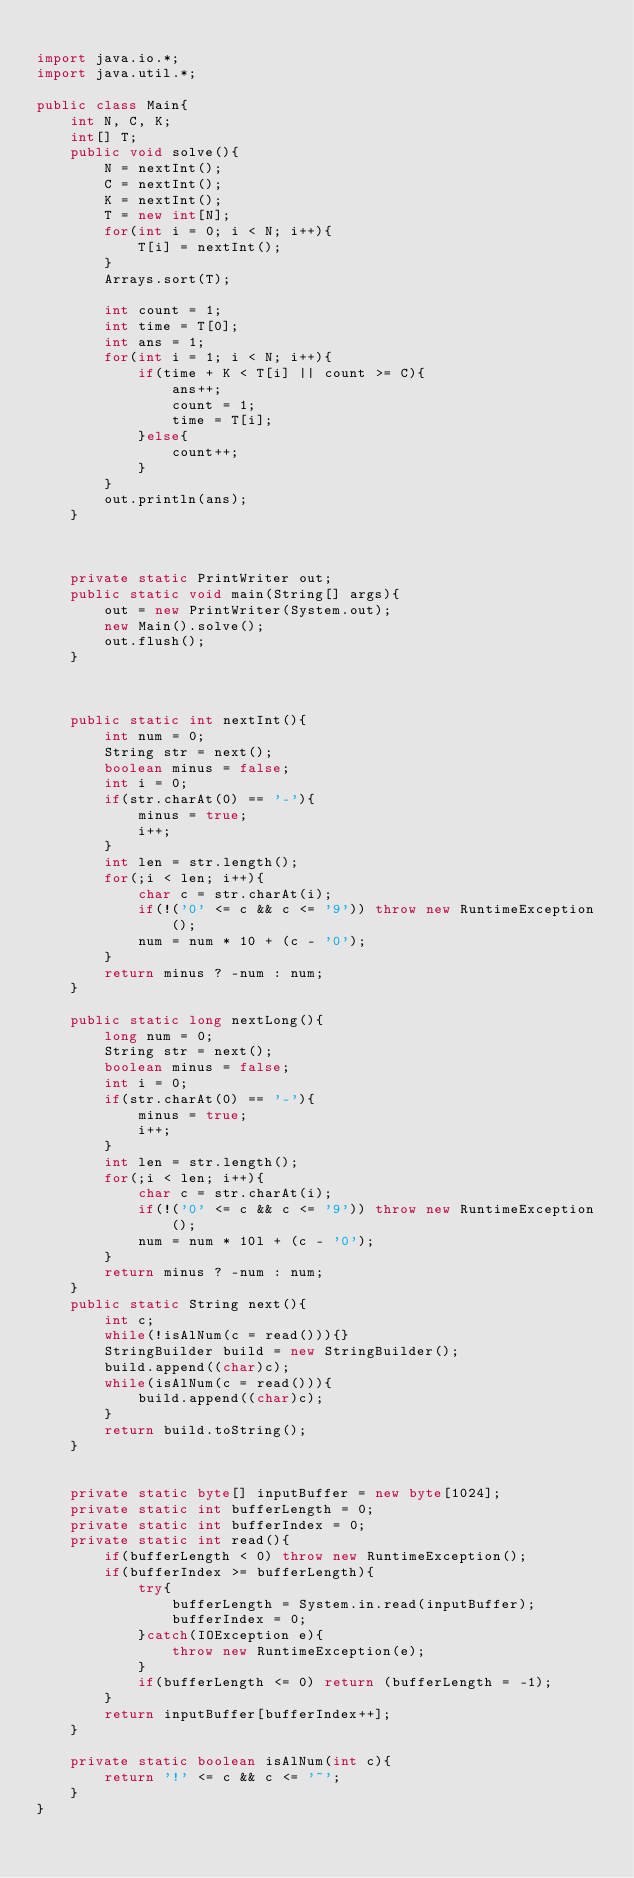Convert code to text. <code><loc_0><loc_0><loc_500><loc_500><_Java_>
import java.io.*;
import java.util.*;
 
public class Main{
	int N, C, K;
	int[] T;
	public void solve(){
		N = nextInt();
		C = nextInt();
		K = nextInt();
		T = new int[N];
		for(int i = 0; i < N; i++){
			T[i] = nextInt();
		}
		Arrays.sort(T);
		
		int count = 1;
		int time = T[0];
		int ans = 1;
		for(int i = 1; i < N; i++){
			if(time + K < T[i] || count >= C){
				ans++;
				count = 1;
				time = T[i];
			}else{
				count++;
			}
		}
		out.println(ans);
	}
	

	
	private static PrintWriter out;
	public static void main(String[] args){
		out = new PrintWriter(System.out);
		new Main().solve();
		out.flush();
	}
	
	
	
	public static int nextInt(){
		int num = 0;
		String str = next();
		boolean minus = false;
		int i = 0;
		if(str.charAt(0) == '-'){
			minus = true;
			i++;
		}
		int len = str.length();
		for(;i < len; i++){
			char c = str.charAt(i);
			if(!('0' <= c && c <= '9')) throw new RuntimeException();
			num = num * 10 + (c - '0');
		}
		return minus ? -num : num;
	}
	
	public static long nextLong(){
		long num = 0;
		String str = next();
		boolean minus = false;
		int i = 0;
		if(str.charAt(0) == '-'){
			minus = true;
			i++;
		}
		int len = str.length();
		for(;i < len; i++){
			char c = str.charAt(i);
			if(!('0' <= c && c <= '9')) throw new RuntimeException();
			num = num * 10l + (c - '0');
		}
		return minus ? -num : num;
	}
	public static String next(){
		int c;
		while(!isAlNum(c = read())){}
		StringBuilder build = new StringBuilder();
		build.append((char)c);
		while(isAlNum(c = read())){
			build.append((char)c);
		}
		return build.toString();
	}
	
	
	private static byte[] inputBuffer = new byte[1024];
	private static int bufferLength = 0;
	private static int bufferIndex = 0;
	private static int read(){
		if(bufferLength < 0) throw new RuntimeException();
		if(bufferIndex >= bufferLength){
			try{
				bufferLength = System.in.read(inputBuffer);
				bufferIndex = 0;
			}catch(IOException e){
				throw new RuntimeException(e);
			}
			if(bufferLength <= 0) return (bufferLength = -1);
		}
		return inputBuffer[bufferIndex++];
	}
	
	private static boolean isAlNum(int c){
		return '!' <= c && c <= '~';
	}
}</code> 